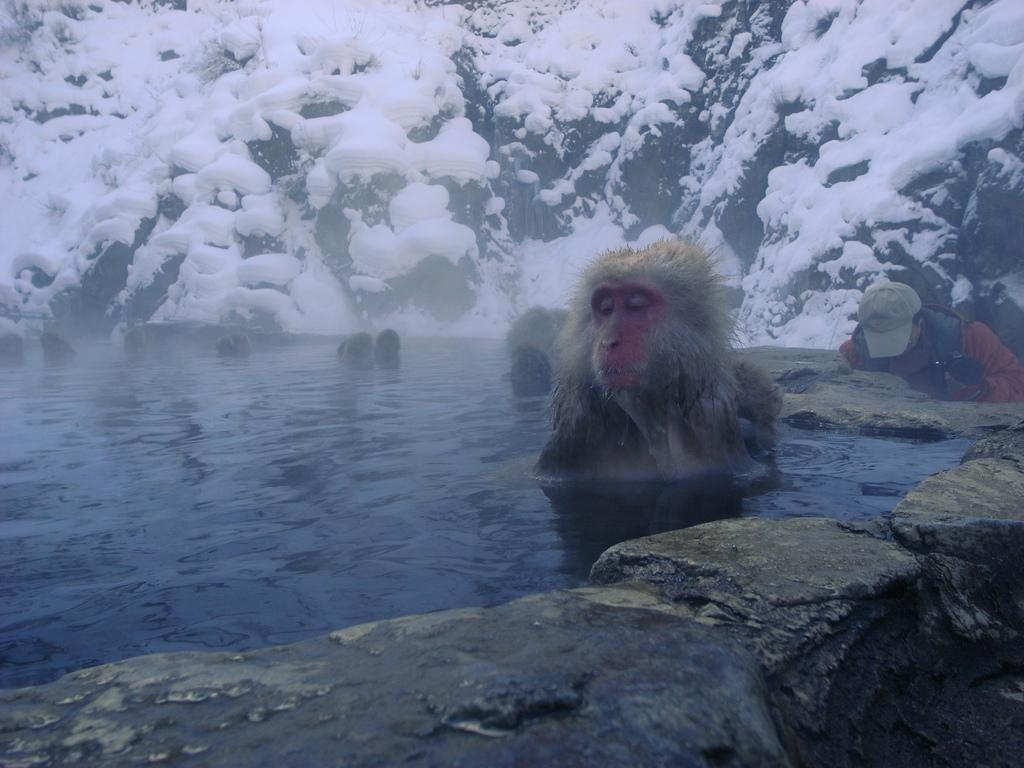Please provide a concise description of this image. In this image I see a monkey over here and I see a person who is wearing a cap and I see the water and I see the rocks. In the background I see the snowy mountain. 